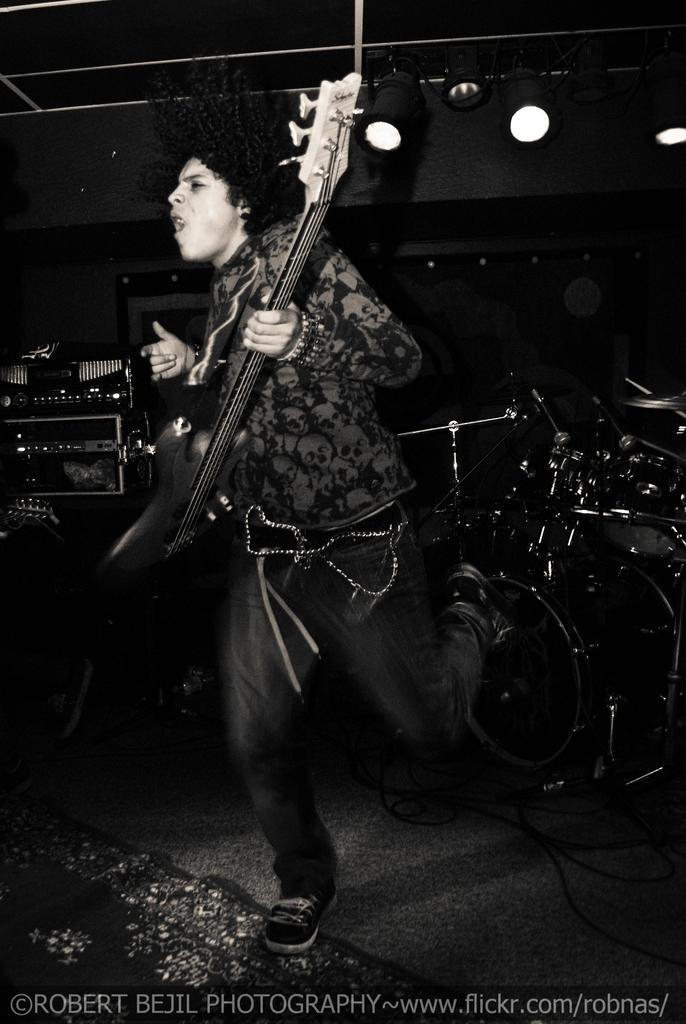What is the person in the image holding? The person in the image is holding a guitar. What other musical instruments can be seen in the image? There are drums visible on the right side of the image. What can be seen in the background of the image? There are lights visible in the background of the image. What type of vegetable is being used as a base for the musical instruments in the image? There are no vegetables present in the image, and the musical instruments are not being supported by any base. 